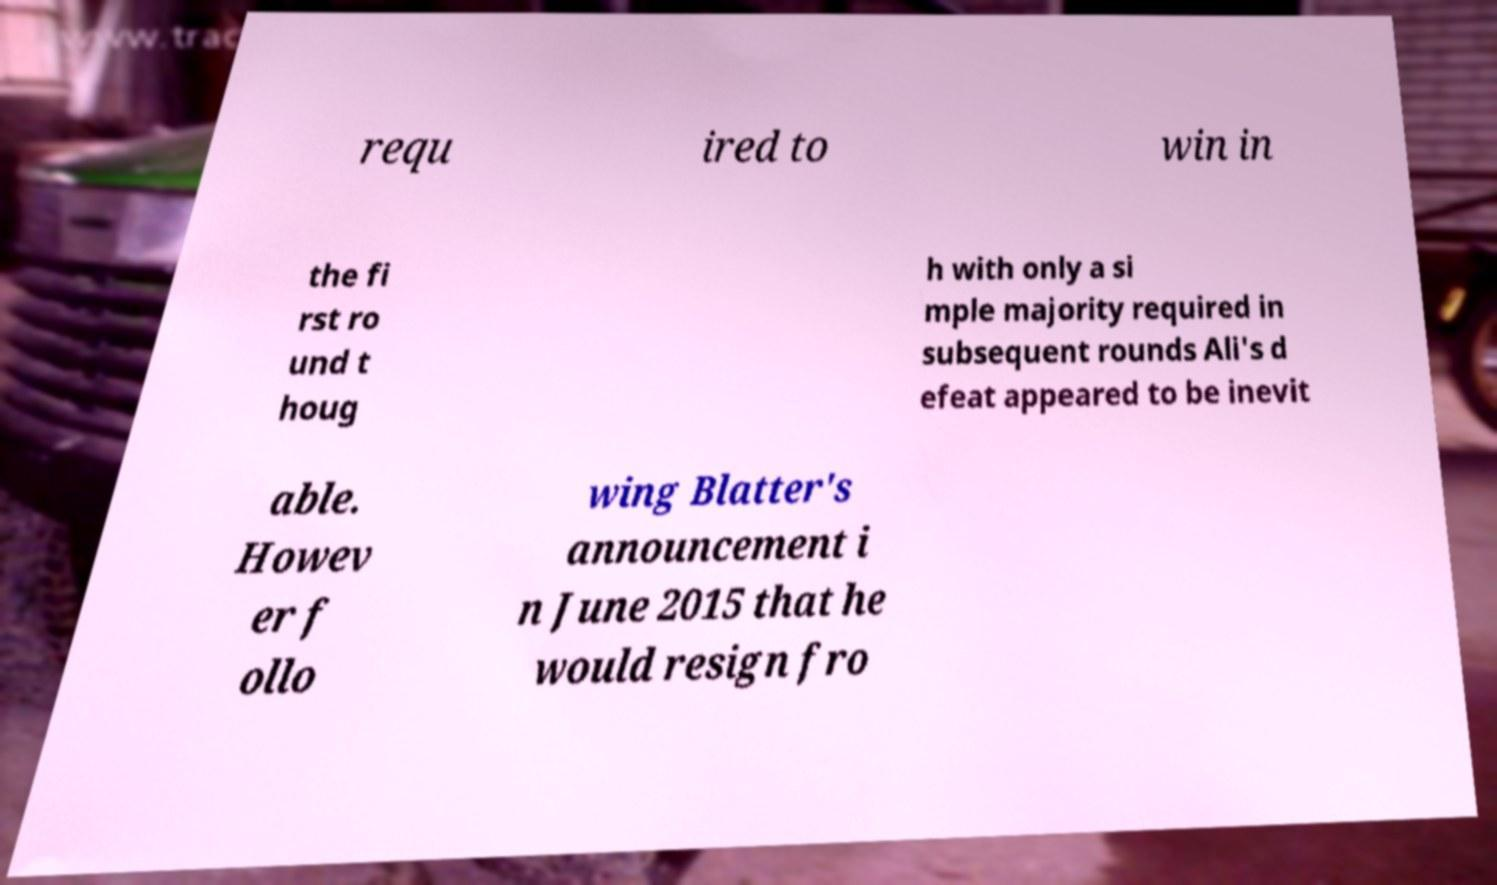There's text embedded in this image that I need extracted. Can you transcribe it verbatim? requ ired to win in the fi rst ro und t houg h with only a si mple majority required in subsequent rounds Ali's d efeat appeared to be inevit able. Howev er f ollo wing Blatter's announcement i n June 2015 that he would resign fro 